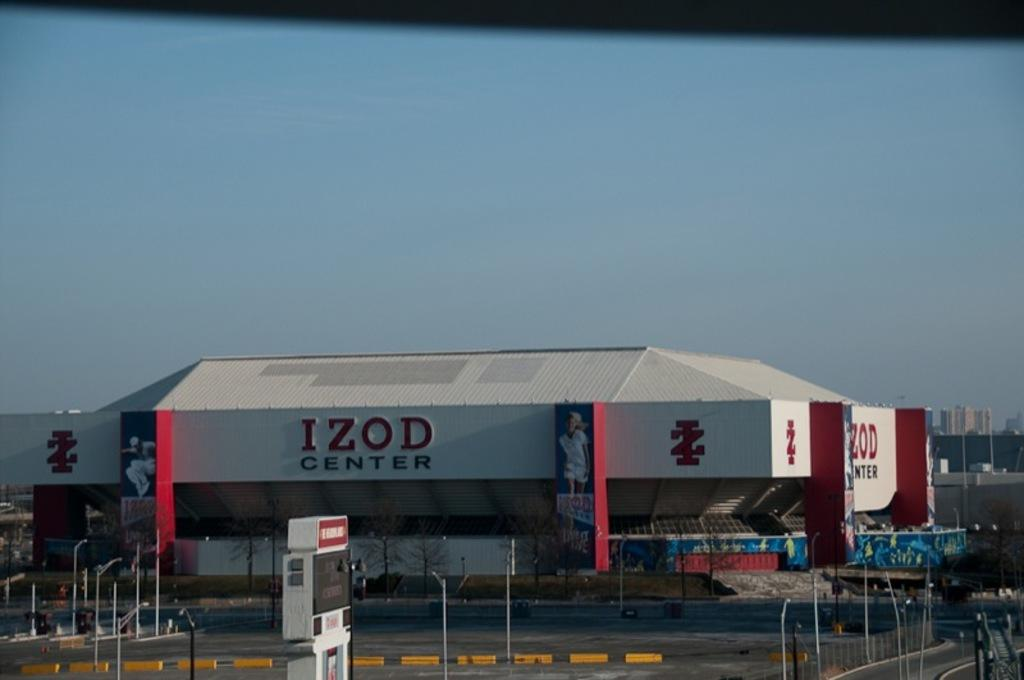What type of structure is in the image? There is a building in the image. What is located at the bottom of the image? There is a road at the bottom of the image. What can be seen in the front of the image? There are many poles in the front of the image. What is visible at the top of the image? The sky is visible at the top of the image. What type of structures are present in the background of the image? Skyscrapers are present in the background of the image. What type of insurance is being discussed by the skyscrapers in the image? There is no discussion or insurance present in the image; it features a building, road, poles, sky, and skyscrapers. 